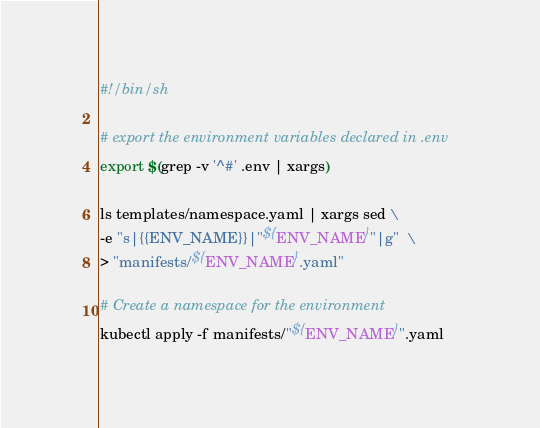<code> <loc_0><loc_0><loc_500><loc_500><_Bash_>#!/bin/sh

# export the environment variables declared in .env
export $(grep -v '^#' .env | xargs)

ls templates/namespace.yaml | xargs sed \
-e "s|{{ENV_NAME}}|"${ENV_NAME}"|g"  \
> "manifests/${ENV_NAME}.yaml"

# Create a namespace for the environment
kubectl apply -f manifests/"${ENV_NAME}".yaml
</code> 